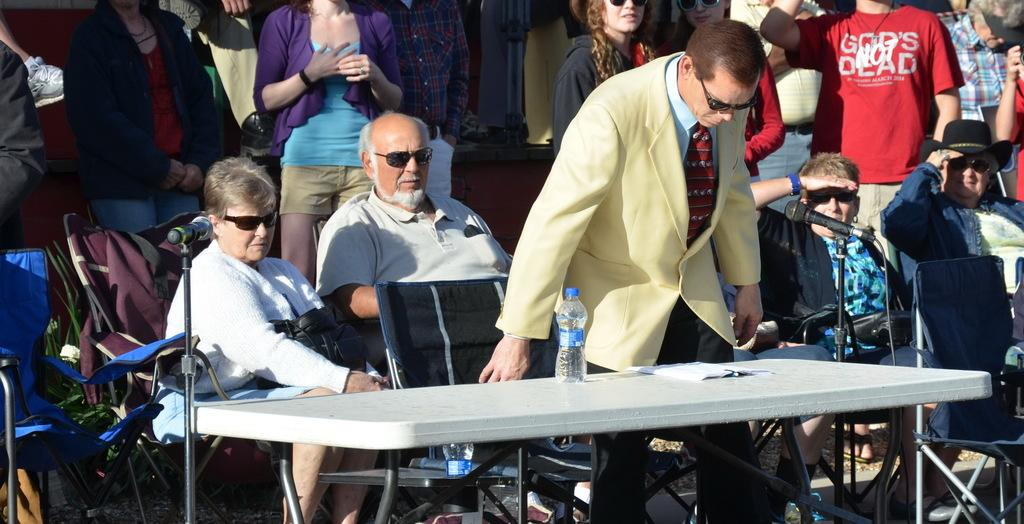What are the people in the image doing? Some people are standing, while others are sitting in the image. What objects are present for the people to use? There are chairs and microphones with stands in the image. What items can be seen on the table in the image? There is a bottle and a book on the table in the image. Can you describe the location of the second bottle in the image? There is a bottle on a surface in the image, but it is not specified which surface. What type of lumber is being used to support the table in the image? There is no lumber visible in the image, and the table's support structure is not mentioned. How much rice is being served in the image? There is no rice present in the image. 